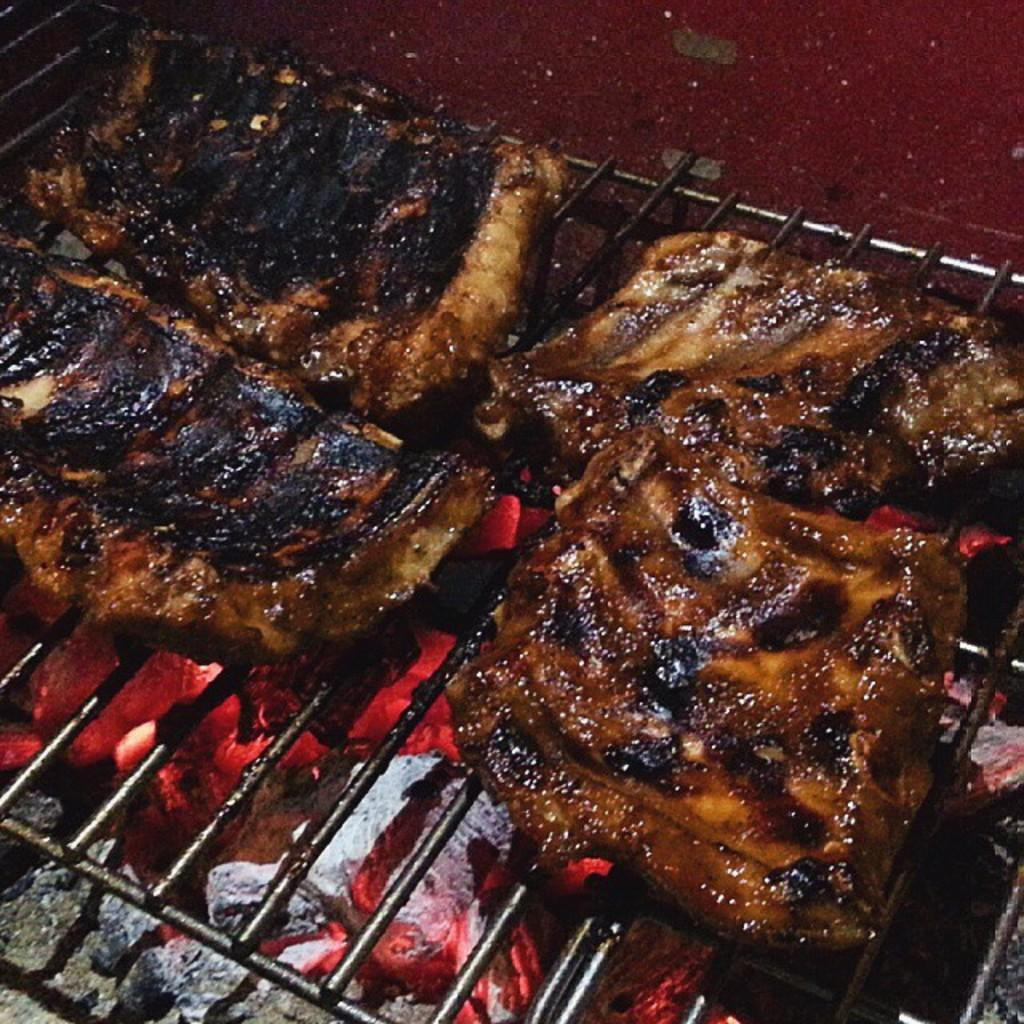What is the main object in the image? There is a grill in the image. What is being cooked on the grill? There is meat on the grill. What is providing heat for the grill? There is burning charcoal below the grill. What type of body is visible in the image? There is no body present in the image; it features a grill with meat and burning charcoal. What mark is left on the meat after it is cooked? The image does not show the cooked meat, so it is not possible to determine what mark is left on the meat. 